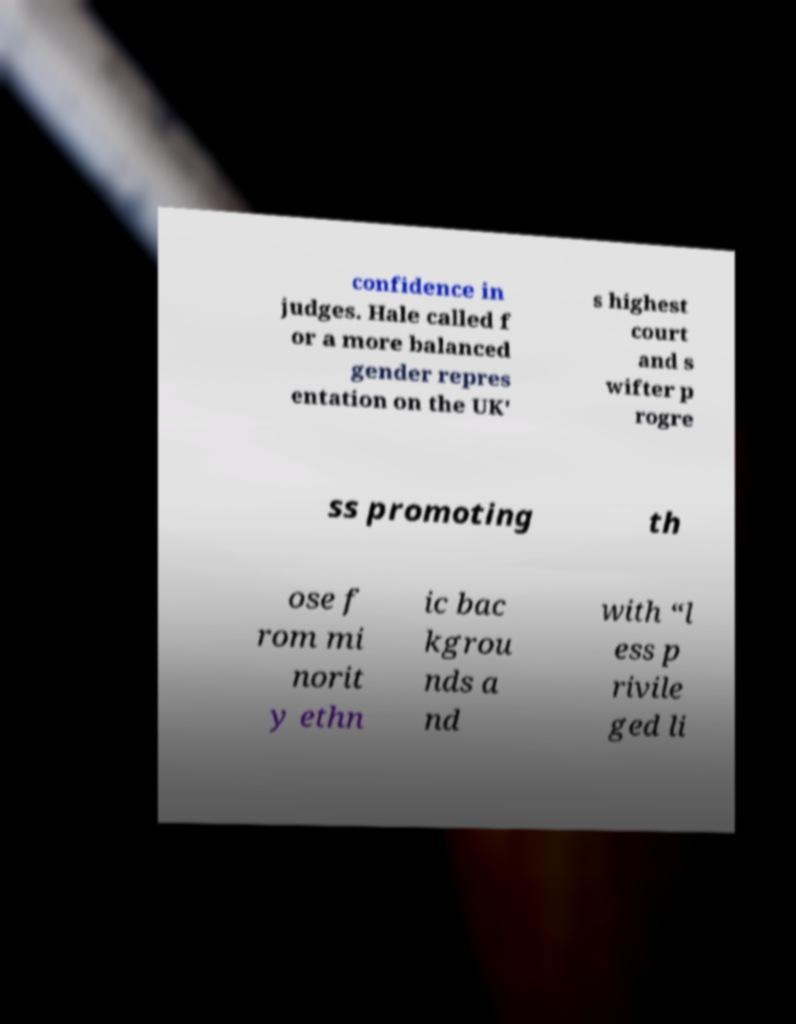Please read and relay the text visible in this image. What does it say? confidence in judges. Hale called f or a more balanced gender repres entation on the UK' s highest court and s wifter p rogre ss promoting th ose f rom mi norit y ethn ic bac kgrou nds a nd with “l ess p rivile ged li 